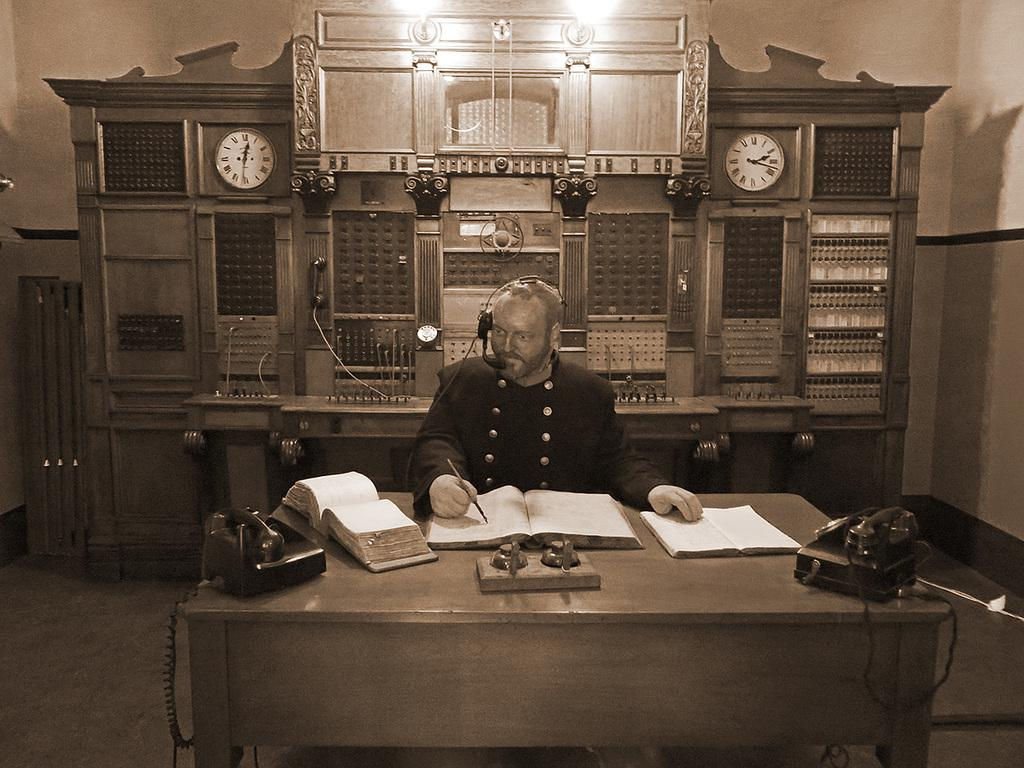What is the person in the image doing? The person is sitting and writing on a book with a pen. What object is the person using to write? The person is using a pen to write. What other objects can be seen in the image? There is a telephone and a clock in the image. What is the background of the image made of? There is a wall in the image. How many spiders are crawling on the telephone in the image? There are no spiders visible in the image, as it only features a person writing, a pen, a telephone, a clock, and a wall. 